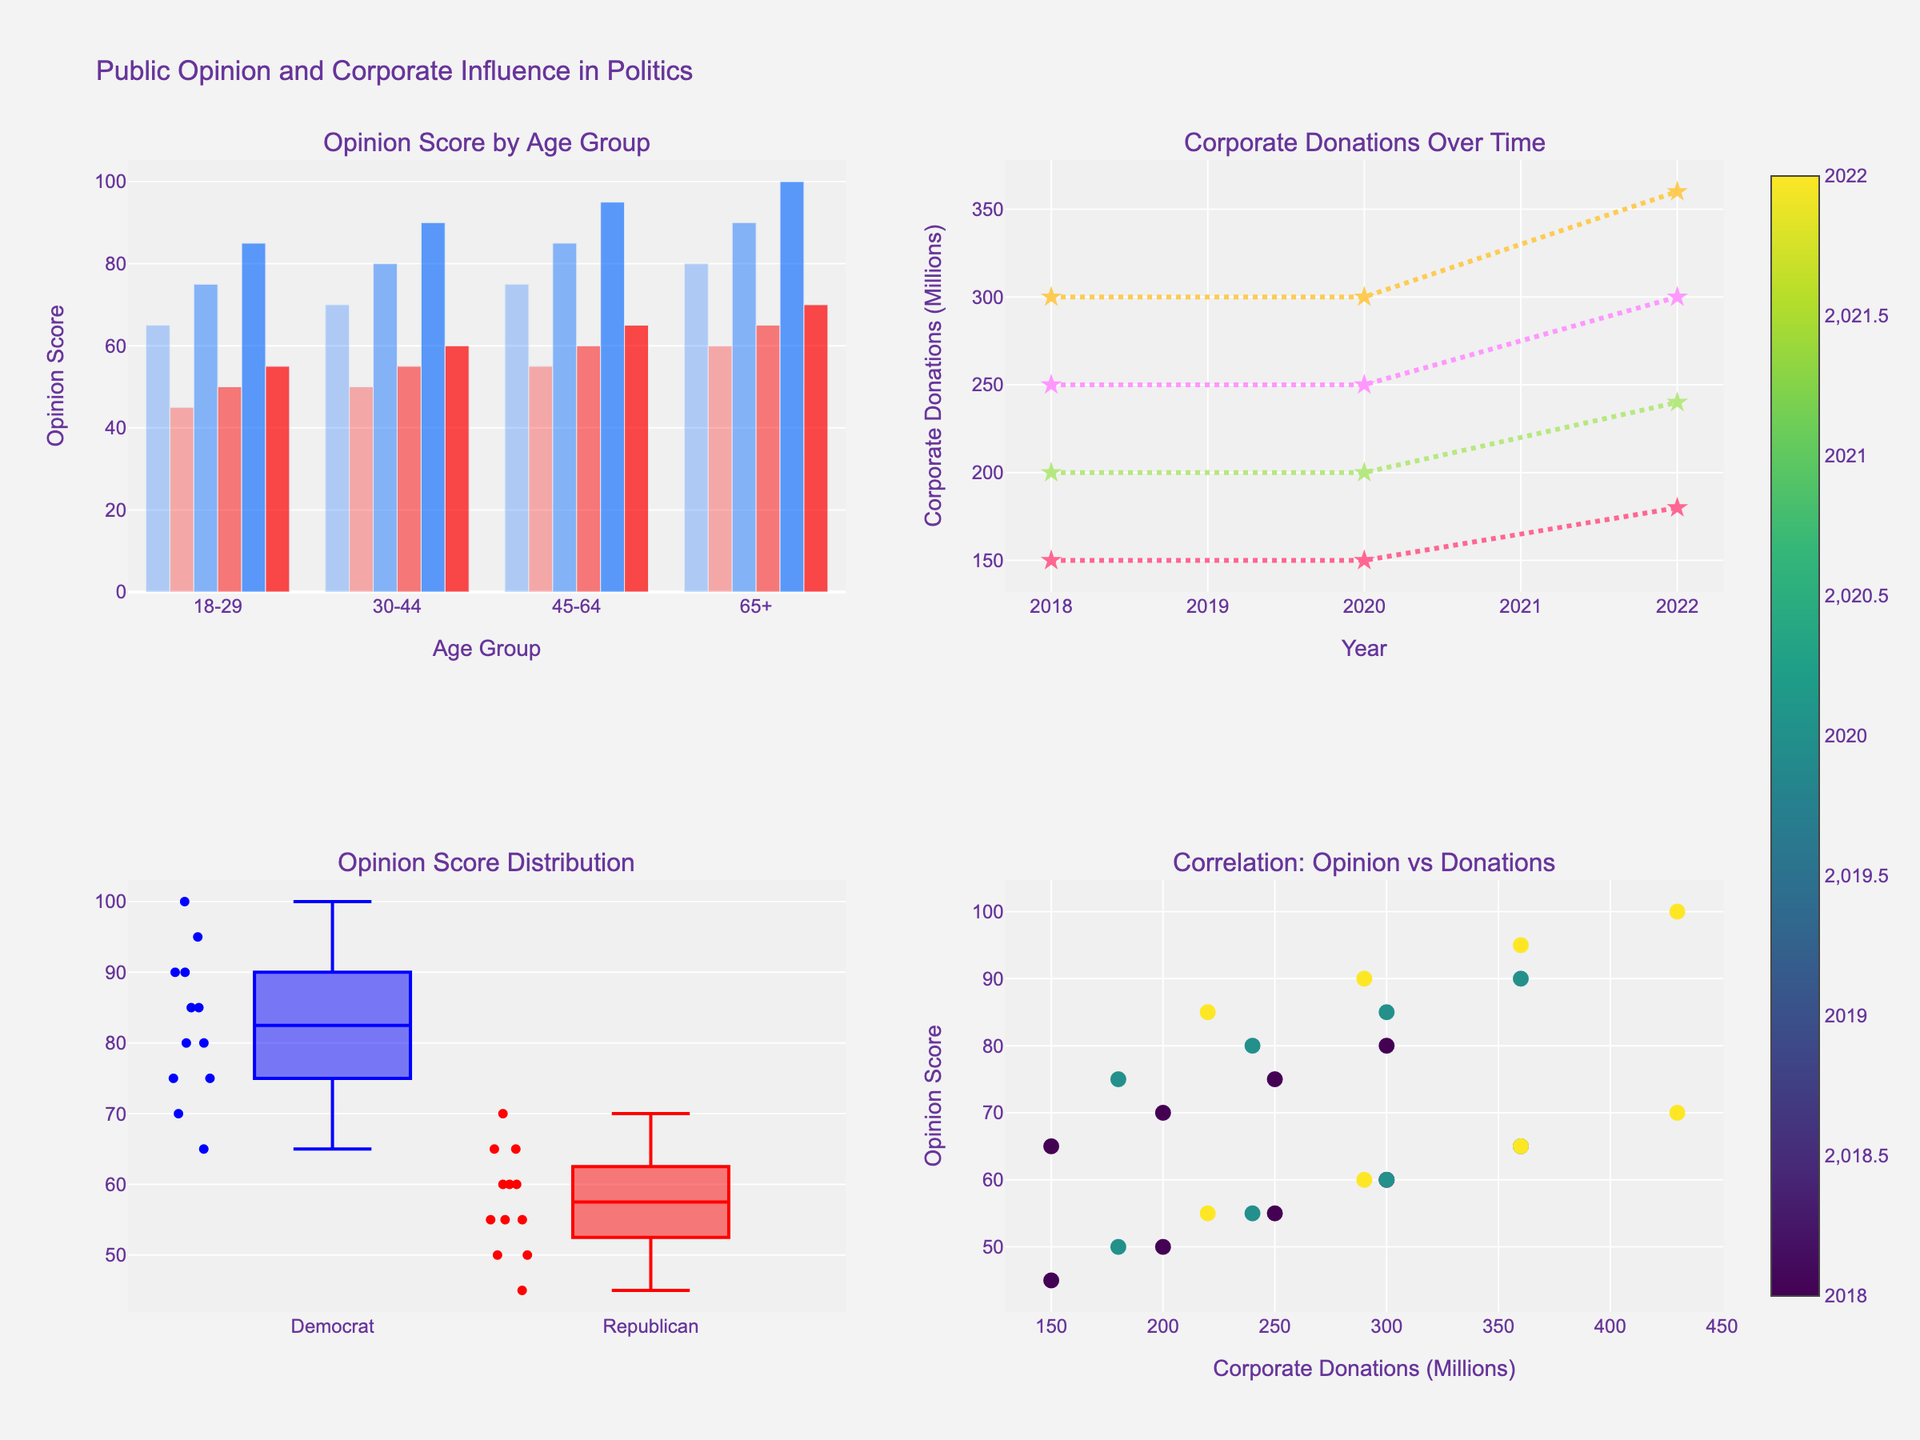What is the title of the figure? The title is located at the top of the figure, usually in larger and bold text for easy identification.
Answer: Public Opinion and Corporate Influence in Politics Which age group had the highest opinion score among Democrats in 2022? Look at the bar chart in the top-left subplot for 2022. The height of the bars for each age group represents the opinion score. Identify which bar is the tallest among Democrats.
Answer: 65+ Has corporate donation increased or decreased over time for the 30-44 age group? Look at the line chart in the top-right subplot. Trace the line corresponding to the 30-44 age group from 2018 to 2022. If the line ascends, donations have increased; if it descends, donations have decreased.
Answer: Increased What is the median opinion score for Republicans based on the box plot? The median is indicated by the line inside the box in the box plot. Look at the box plot in the bottom-left subplot for the Republican group.
Answer: 60 Compare the change in opinion score from 2018 to 2022 for 18-29-year-old Republicans and Democrats. Who saw a bigger increase? Use the bar chart in the top-left subplot. Measure the difference in bar heights from 2018 to 2022 for the 18-29 Republican and Democrat groups. Compare the changes.
Answer: Democrats Which age group shows the star markers in the line chart for corporate donations over time? Look at the line chart in the top-right subplot. Each line is marked distinctly. Identify which line has star markers.
Answer: All age groups How does the opinion score correlate with corporate donations in 2022? Use the scatter plot in the bottom-right subplot. Observe the trend of data points for the year 2022 (check the color scale). Determine if there is a positive, negative, or no clear correlation.
Answer: Positive correlation In the bottom-right scatter plot, what does the color of the markers represent? Check the legend or the labels on the color scale of the scatter plot. The color usually represents a variable or category.
Answer: Year 